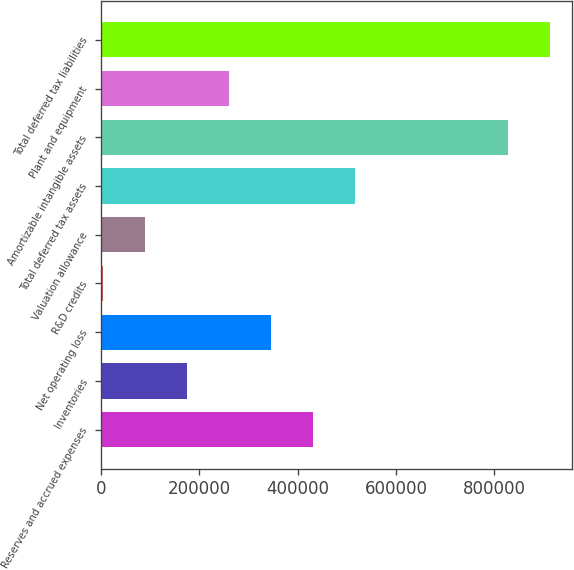Convert chart to OTSL. <chart><loc_0><loc_0><loc_500><loc_500><bar_chart><fcel>Reserves and accrued expenses<fcel>Inventories<fcel>Net operating loss<fcel>R&D credits<fcel>Valuation allowance<fcel>Total deferred tax assets<fcel>Amortizable intangible assets<fcel>Plant and equipment<fcel>Total deferred tax liabilities<nl><fcel>431695<fcel>174558<fcel>345983<fcel>3134<fcel>88846.2<fcel>517407<fcel>826838<fcel>260271<fcel>912550<nl></chart> 